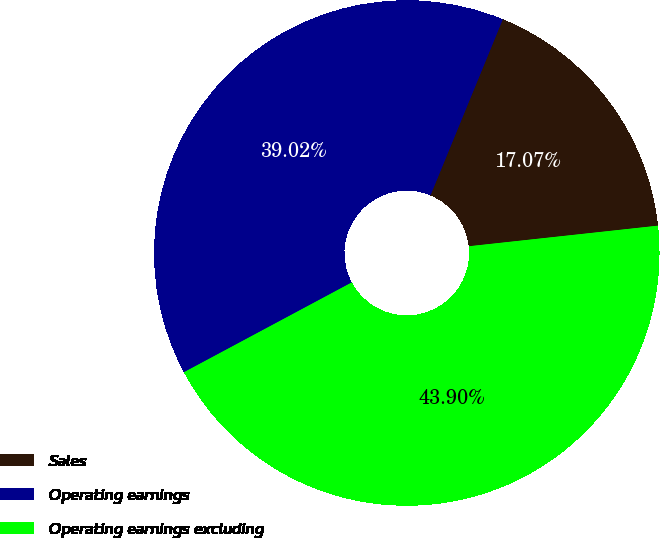Convert chart to OTSL. <chart><loc_0><loc_0><loc_500><loc_500><pie_chart><fcel>Sales<fcel>Operating earnings<fcel>Operating earnings excluding<nl><fcel>17.07%<fcel>39.02%<fcel>43.9%<nl></chart> 